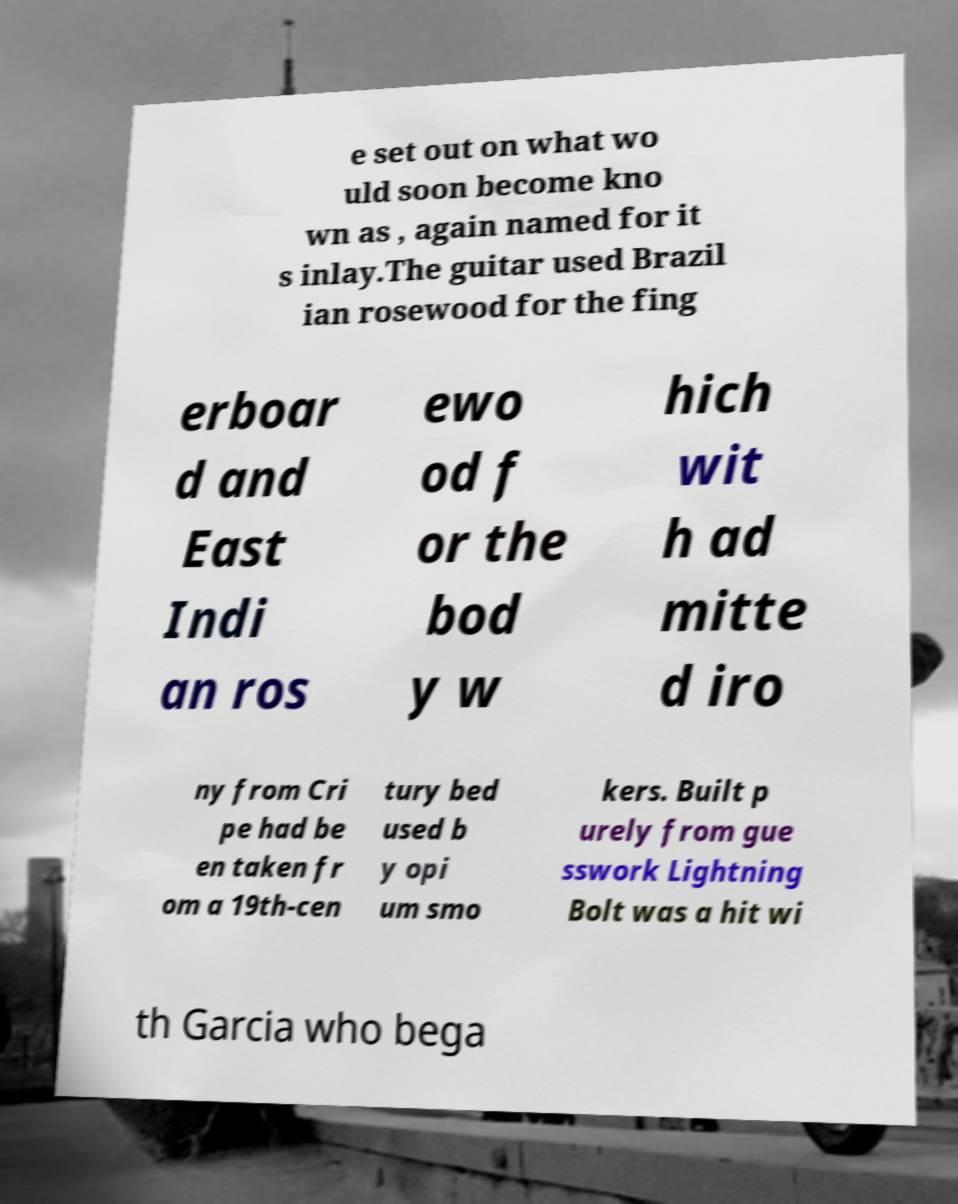What messages or text are displayed in this image? I need them in a readable, typed format. e set out on what wo uld soon become kno wn as , again named for it s inlay.The guitar used Brazil ian rosewood for the fing erboar d and East Indi an ros ewo od f or the bod y w hich wit h ad mitte d iro ny from Cri pe had be en taken fr om a 19th-cen tury bed used b y opi um smo kers. Built p urely from gue sswork Lightning Bolt was a hit wi th Garcia who bega 